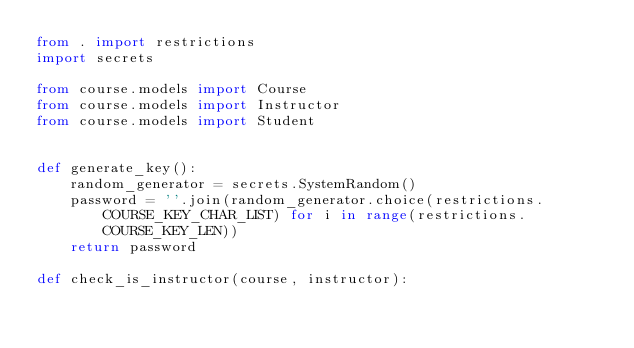<code> <loc_0><loc_0><loc_500><loc_500><_Python_>from . import restrictions
import secrets

from course.models import Course
from course.models import Instructor
from course.models import Student


def generate_key():
	random_generator = secrets.SystemRandom()
	password = ''.join(random_generator.choice(restrictions.COURSE_KEY_CHAR_LIST) for i in range(restrictions.COURSE_KEY_LEN))
	return password

def check_is_instructor(course, instructor):</code> 